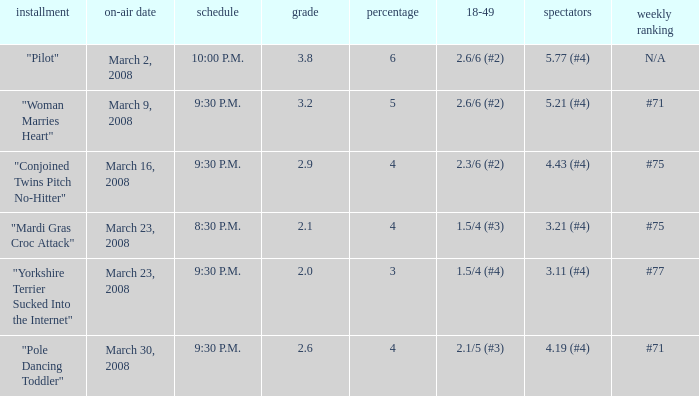What is the total ratings on share less than 4? 1.0. 